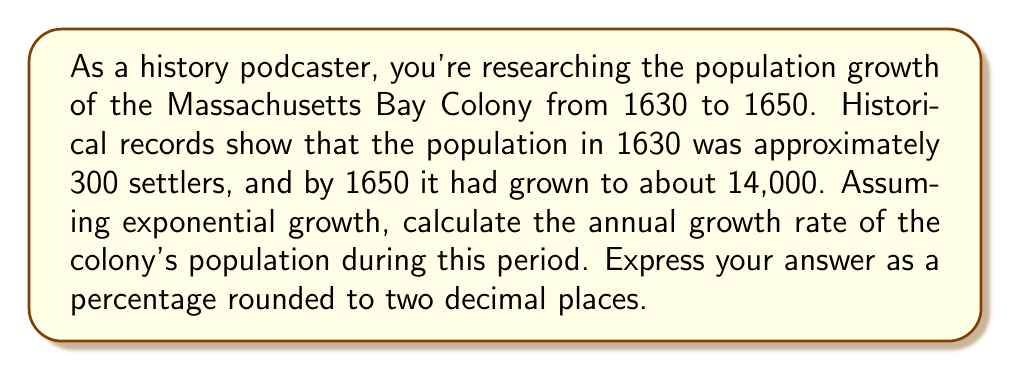Give your solution to this math problem. To solve this problem, we'll use the exponential growth model:

$$P(t) = P_0 e^{rt}$$

Where:
$P(t)$ is the population at time $t$
$P_0$ is the initial population
$r$ is the growth rate
$t$ is the time in years

We know:
$P_0 = 300$ (population in 1630)
$P(20) = 14000$ (population in 1650, 20 years later)
$t = 20$ years

Let's plug these values into the equation:

$$14000 = 300 e^{r(20)}$$

Now, let's solve for $r$:

1) Divide both sides by 300:
   $$\frac{14000}{300} = e^{20r}$$

2) Take the natural log of both sides:
   $$\ln(\frac{14000}{300}) = 20r$$

3) Simplify:
   $$\ln(46.67) = 20r$$

4) Solve for $r$:
   $$r = \frac{\ln(46.67)}{20}$$

5) Calculate:
   $$r = \frac{3.8430}{20} = 0.19215$$

6) Convert to a percentage:
   $$0.19215 \times 100 = 19.215\%$$

7) Round to two decimal places:
   $$19.22\%$$
Answer: The annual population growth rate of the Massachusetts Bay Colony from 1630 to 1650 was approximately 19.22%. 